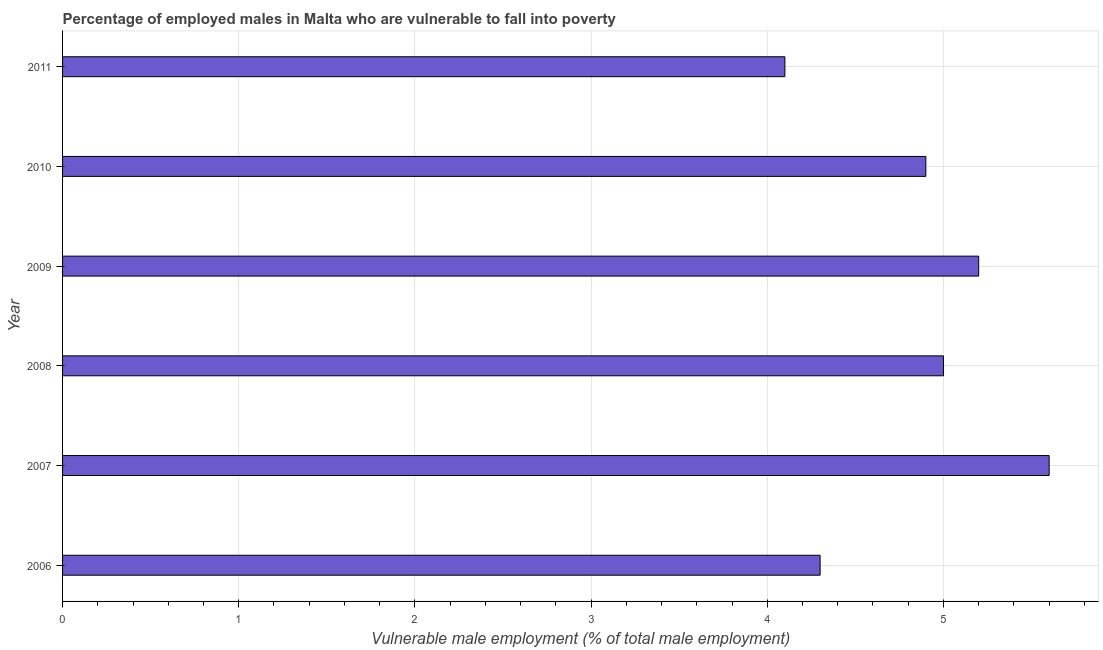What is the title of the graph?
Keep it short and to the point. Percentage of employed males in Malta who are vulnerable to fall into poverty. What is the label or title of the X-axis?
Your answer should be compact. Vulnerable male employment (% of total male employment). What is the percentage of employed males who are vulnerable to fall into poverty in 2007?
Provide a short and direct response. 5.6. Across all years, what is the maximum percentage of employed males who are vulnerable to fall into poverty?
Provide a short and direct response. 5.6. Across all years, what is the minimum percentage of employed males who are vulnerable to fall into poverty?
Give a very brief answer. 4.1. In which year was the percentage of employed males who are vulnerable to fall into poverty maximum?
Your response must be concise. 2007. In which year was the percentage of employed males who are vulnerable to fall into poverty minimum?
Offer a very short reply. 2011. What is the sum of the percentage of employed males who are vulnerable to fall into poverty?
Make the answer very short. 29.1. What is the difference between the percentage of employed males who are vulnerable to fall into poverty in 2007 and 2008?
Offer a terse response. 0.6. What is the average percentage of employed males who are vulnerable to fall into poverty per year?
Keep it short and to the point. 4.85. What is the median percentage of employed males who are vulnerable to fall into poverty?
Offer a terse response. 4.95. In how many years, is the percentage of employed males who are vulnerable to fall into poverty greater than 4.6 %?
Your response must be concise. 4. Do a majority of the years between 2008 and 2010 (inclusive) have percentage of employed males who are vulnerable to fall into poverty greater than 0.4 %?
Your answer should be compact. Yes. What is the ratio of the percentage of employed males who are vulnerable to fall into poverty in 2006 to that in 2010?
Keep it short and to the point. 0.88. Is the percentage of employed males who are vulnerable to fall into poverty in 2007 less than that in 2008?
Your answer should be very brief. No. Is the difference between the percentage of employed males who are vulnerable to fall into poverty in 2006 and 2010 greater than the difference between any two years?
Your response must be concise. No. Is the sum of the percentage of employed males who are vulnerable to fall into poverty in 2008 and 2010 greater than the maximum percentage of employed males who are vulnerable to fall into poverty across all years?
Offer a very short reply. Yes. What is the difference between the highest and the lowest percentage of employed males who are vulnerable to fall into poverty?
Provide a short and direct response. 1.5. How many years are there in the graph?
Offer a terse response. 6. Are the values on the major ticks of X-axis written in scientific E-notation?
Keep it short and to the point. No. What is the Vulnerable male employment (% of total male employment) in 2006?
Your response must be concise. 4.3. What is the Vulnerable male employment (% of total male employment) of 2007?
Your answer should be compact. 5.6. What is the Vulnerable male employment (% of total male employment) of 2009?
Give a very brief answer. 5.2. What is the Vulnerable male employment (% of total male employment) of 2010?
Keep it short and to the point. 4.9. What is the Vulnerable male employment (% of total male employment) of 2011?
Your answer should be compact. 4.1. What is the difference between the Vulnerable male employment (% of total male employment) in 2007 and 2010?
Your answer should be very brief. 0.7. What is the difference between the Vulnerable male employment (% of total male employment) in 2007 and 2011?
Offer a terse response. 1.5. What is the difference between the Vulnerable male employment (% of total male employment) in 2008 and 2009?
Provide a succinct answer. -0.2. What is the difference between the Vulnerable male employment (% of total male employment) in 2008 and 2010?
Your answer should be compact. 0.1. What is the difference between the Vulnerable male employment (% of total male employment) in 2008 and 2011?
Provide a succinct answer. 0.9. What is the difference between the Vulnerable male employment (% of total male employment) in 2009 and 2011?
Your answer should be compact. 1.1. What is the difference between the Vulnerable male employment (% of total male employment) in 2010 and 2011?
Ensure brevity in your answer.  0.8. What is the ratio of the Vulnerable male employment (% of total male employment) in 2006 to that in 2007?
Your answer should be very brief. 0.77. What is the ratio of the Vulnerable male employment (% of total male employment) in 2006 to that in 2008?
Keep it short and to the point. 0.86. What is the ratio of the Vulnerable male employment (% of total male employment) in 2006 to that in 2009?
Your answer should be very brief. 0.83. What is the ratio of the Vulnerable male employment (% of total male employment) in 2006 to that in 2010?
Provide a succinct answer. 0.88. What is the ratio of the Vulnerable male employment (% of total male employment) in 2006 to that in 2011?
Ensure brevity in your answer.  1.05. What is the ratio of the Vulnerable male employment (% of total male employment) in 2007 to that in 2008?
Give a very brief answer. 1.12. What is the ratio of the Vulnerable male employment (% of total male employment) in 2007 to that in 2009?
Your answer should be very brief. 1.08. What is the ratio of the Vulnerable male employment (% of total male employment) in 2007 to that in 2010?
Your answer should be very brief. 1.14. What is the ratio of the Vulnerable male employment (% of total male employment) in 2007 to that in 2011?
Ensure brevity in your answer.  1.37. What is the ratio of the Vulnerable male employment (% of total male employment) in 2008 to that in 2009?
Your answer should be compact. 0.96. What is the ratio of the Vulnerable male employment (% of total male employment) in 2008 to that in 2010?
Offer a very short reply. 1.02. What is the ratio of the Vulnerable male employment (% of total male employment) in 2008 to that in 2011?
Provide a short and direct response. 1.22. What is the ratio of the Vulnerable male employment (% of total male employment) in 2009 to that in 2010?
Provide a short and direct response. 1.06. What is the ratio of the Vulnerable male employment (% of total male employment) in 2009 to that in 2011?
Your answer should be compact. 1.27. What is the ratio of the Vulnerable male employment (% of total male employment) in 2010 to that in 2011?
Your answer should be very brief. 1.2. 